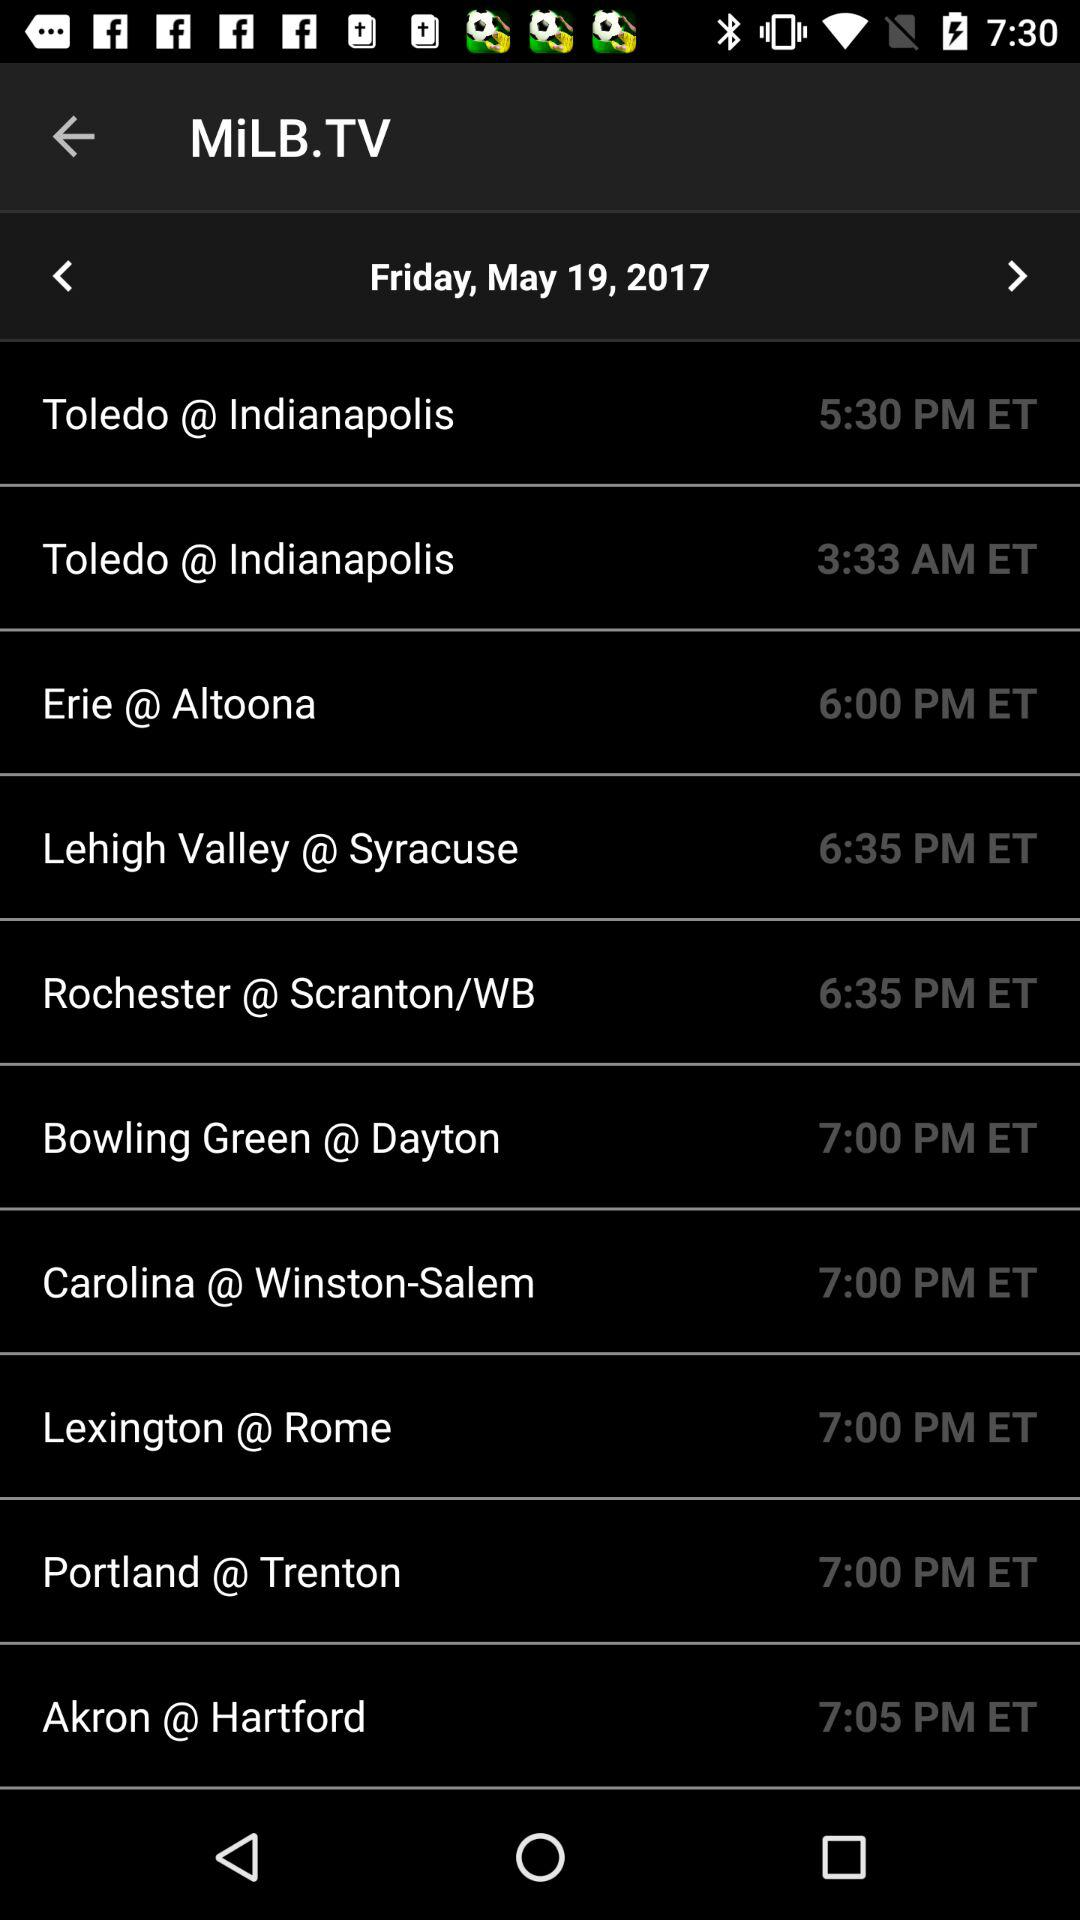Which city's time is 7:05 pm? The city name is "Akron @ Hartford". 